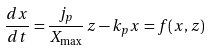Convert formula to latex. <formula><loc_0><loc_0><loc_500><loc_500>\frac { d x } { d t } = \frac { j _ { p } } { X _ { \max } } \, z - k _ { p } x = f ( x , z )</formula> 